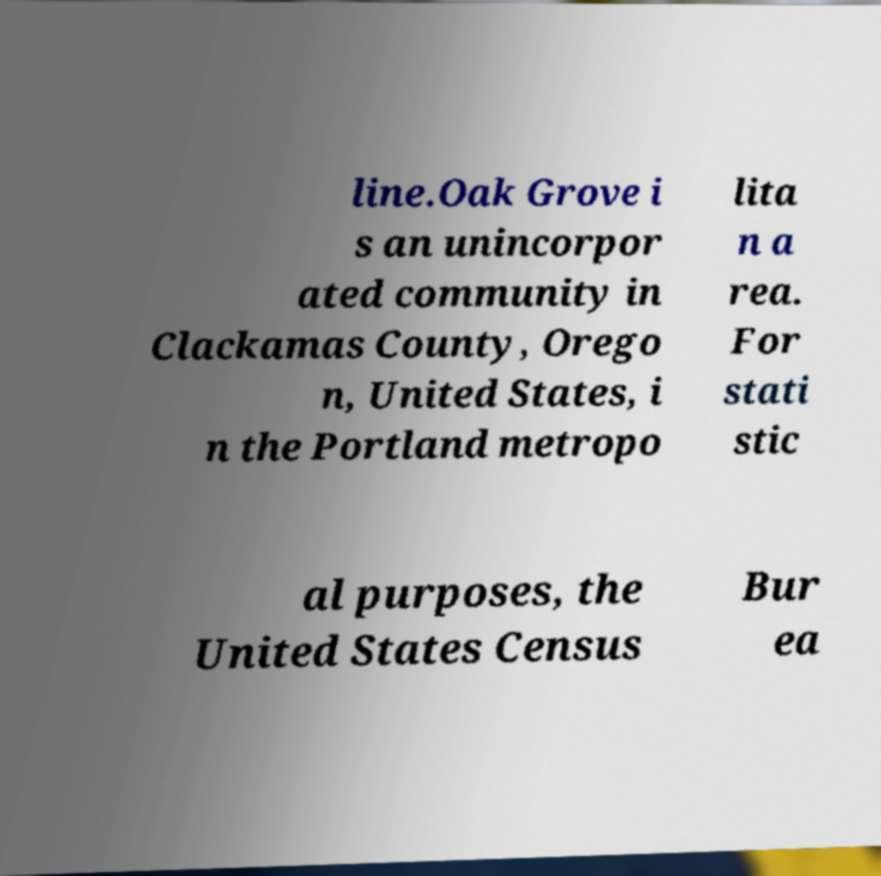For documentation purposes, I need the text within this image transcribed. Could you provide that? line.Oak Grove i s an unincorpor ated community in Clackamas County, Orego n, United States, i n the Portland metropo lita n a rea. For stati stic al purposes, the United States Census Bur ea 